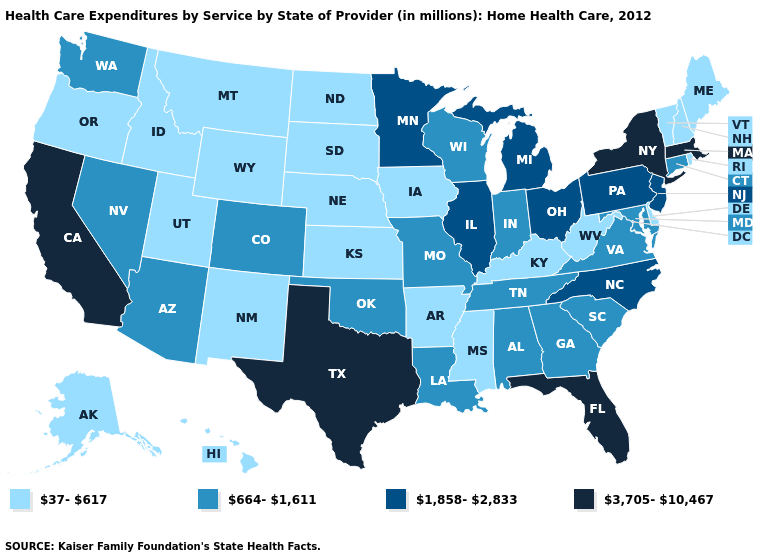Name the states that have a value in the range 37-617?
Concise answer only. Alaska, Arkansas, Delaware, Hawaii, Idaho, Iowa, Kansas, Kentucky, Maine, Mississippi, Montana, Nebraska, New Hampshire, New Mexico, North Dakota, Oregon, Rhode Island, South Dakota, Utah, Vermont, West Virginia, Wyoming. Which states have the lowest value in the USA?
Write a very short answer. Alaska, Arkansas, Delaware, Hawaii, Idaho, Iowa, Kansas, Kentucky, Maine, Mississippi, Montana, Nebraska, New Hampshire, New Mexico, North Dakota, Oregon, Rhode Island, South Dakota, Utah, Vermont, West Virginia, Wyoming. Name the states that have a value in the range 37-617?
Short answer required. Alaska, Arkansas, Delaware, Hawaii, Idaho, Iowa, Kansas, Kentucky, Maine, Mississippi, Montana, Nebraska, New Hampshire, New Mexico, North Dakota, Oregon, Rhode Island, South Dakota, Utah, Vermont, West Virginia, Wyoming. What is the highest value in the USA?
Write a very short answer. 3,705-10,467. Does Maryland have a higher value than Kentucky?
Short answer required. Yes. Name the states that have a value in the range 1,858-2,833?
Give a very brief answer. Illinois, Michigan, Minnesota, New Jersey, North Carolina, Ohio, Pennsylvania. What is the lowest value in states that border Delaware?
Be succinct. 664-1,611. What is the value of Michigan?
Keep it brief. 1,858-2,833. What is the value of Nevada?
Short answer required. 664-1,611. Among the states that border Ohio , does Kentucky have the highest value?
Be succinct. No. Does North Carolina have a lower value than California?
Keep it brief. Yes. Does Utah have the highest value in the USA?
Keep it brief. No. What is the value of Missouri?
Keep it brief. 664-1,611. Name the states that have a value in the range 37-617?
Quick response, please. Alaska, Arkansas, Delaware, Hawaii, Idaho, Iowa, Kansas, Kentucky, Maine, Mississippi, Montana, Nebraska, New Hampshire, New Mexico, North Dakota, Oregon, Rhode Island, South Dakota, Utah, Vermont, West Virginia, Wyoming. Which states hav the highest value in the MidWest?
Write a very short answer. Illinois, Michigan, Minnesota, Ohio. 